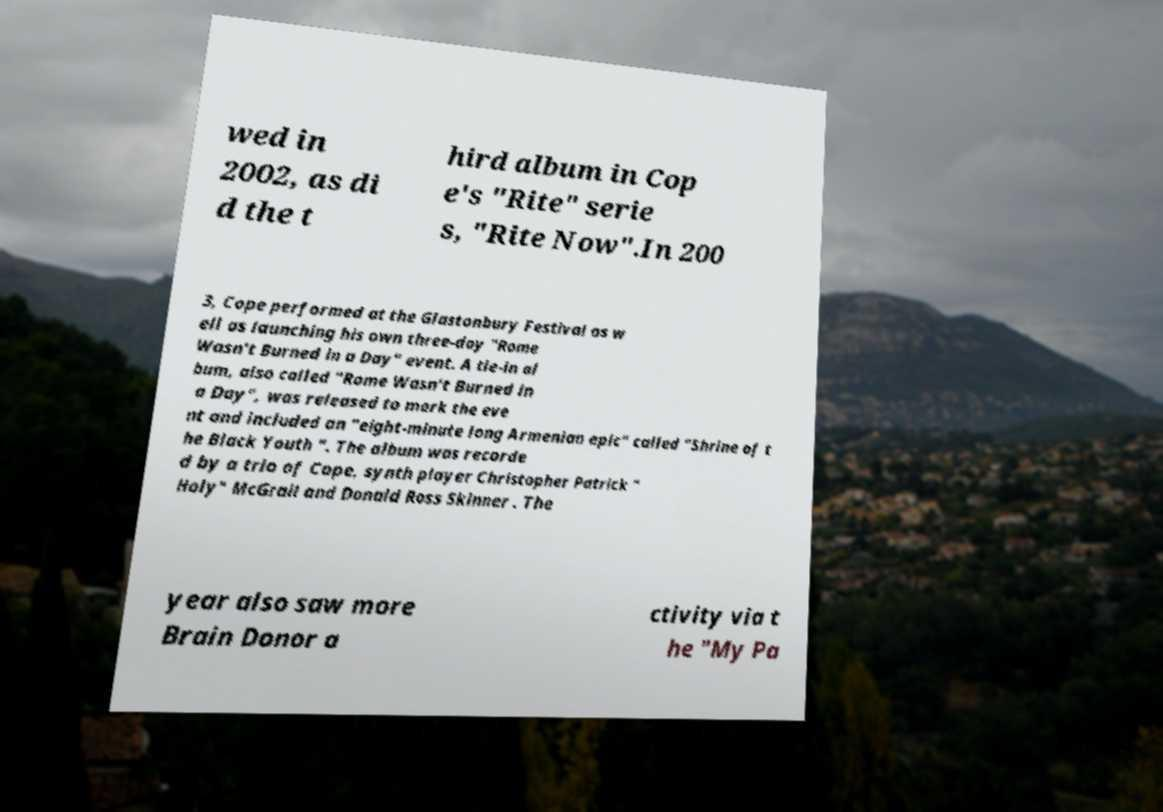For documentation purposes, I need the text within this image transcribed. Could you provide that? wed in 2002, as di d the t hird album in Cop e's "Rite" serie s, "Rite Now".In 200 3, Cope performed at the Glastonbury Festival as w ell as launching his own three-day "Rome Wasn't Burned in a Day" event. A tie-in al bum, also called "Rome Wasn't Burned in a Day", was released to mark the eve nt and included an "eight-minute long Armenian epic" called "Shrine of t he Black Youth ". The album was recorde d by a trio of Cope, synth player Christopher Patrick " Holy" McGrail and Donald Ross Skinner . The year also saw more Brain Donor a ctivity via t he "My Pa 